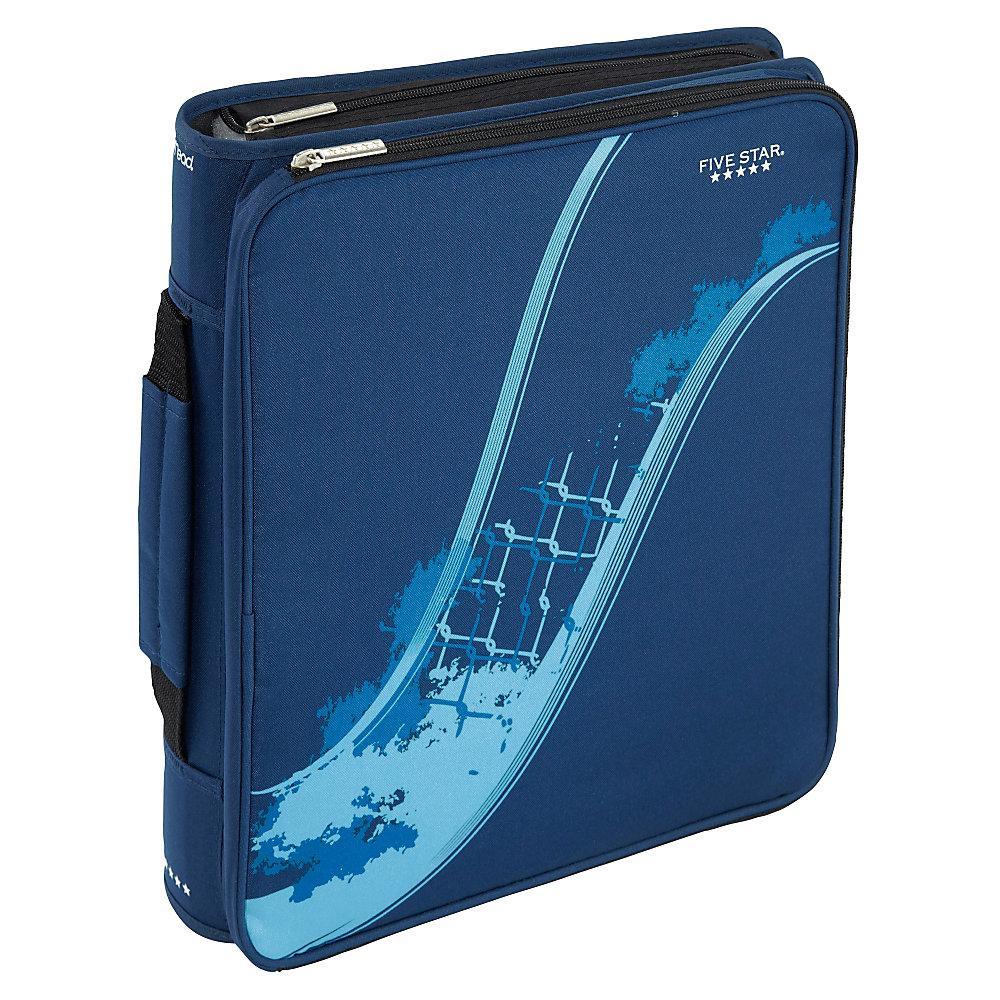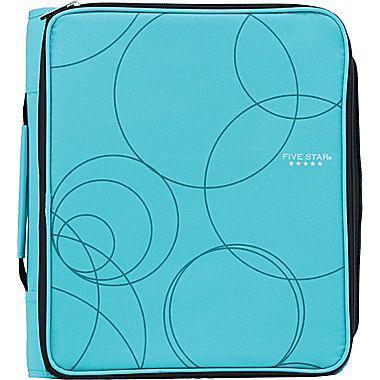The first image is the image on the left, the second image is the image on the right. Examine the images to the left and right. Is the description "The open trapper keeper is filled with paper and other items" accurate? Answer yes or no. No. The first image is the image on the left, the second image is the image on the right. For the images shown, is this caption "The open notebooks contain multiple items; they are not empty." true? Answer yes or no. No. 